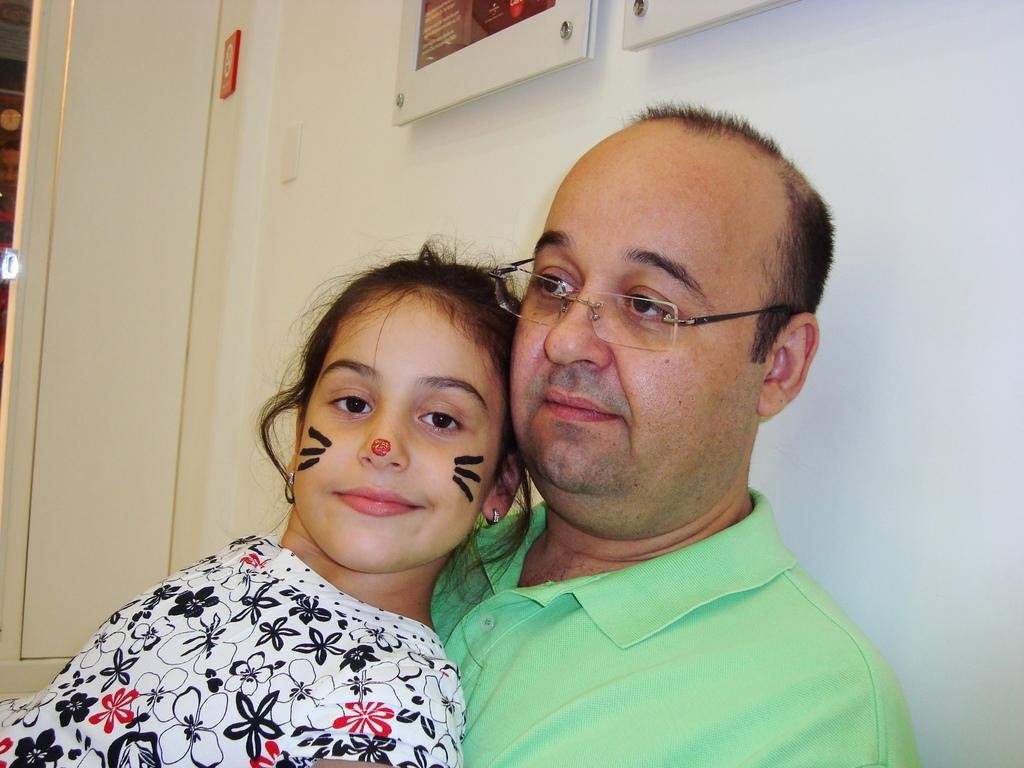Who are the people in the image? There is a man and a girl in the image. What can be seen in the background of the image? There is a wall and a door in the background. What is placed on the wall? There are frames placed on the wall. What type of game is the man playing with the girl in the image? There is no game being played in the image; the man and the girl are simply standing in front of a wall with frames. 